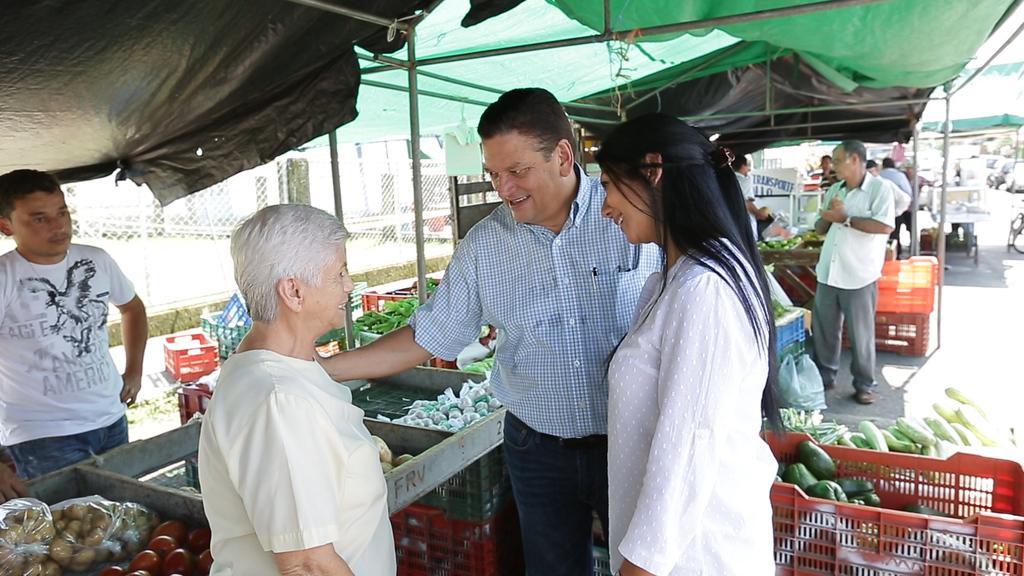How would you summarize this image in a sentence or two? In this picture we can see the stalls, mesh and the people. In the middle portion of the picture we can see the people standing and it seems like they are talking. We can see vegetables and the containers. On the right side of the picture we can see the road and far it seems like the vehicles. 